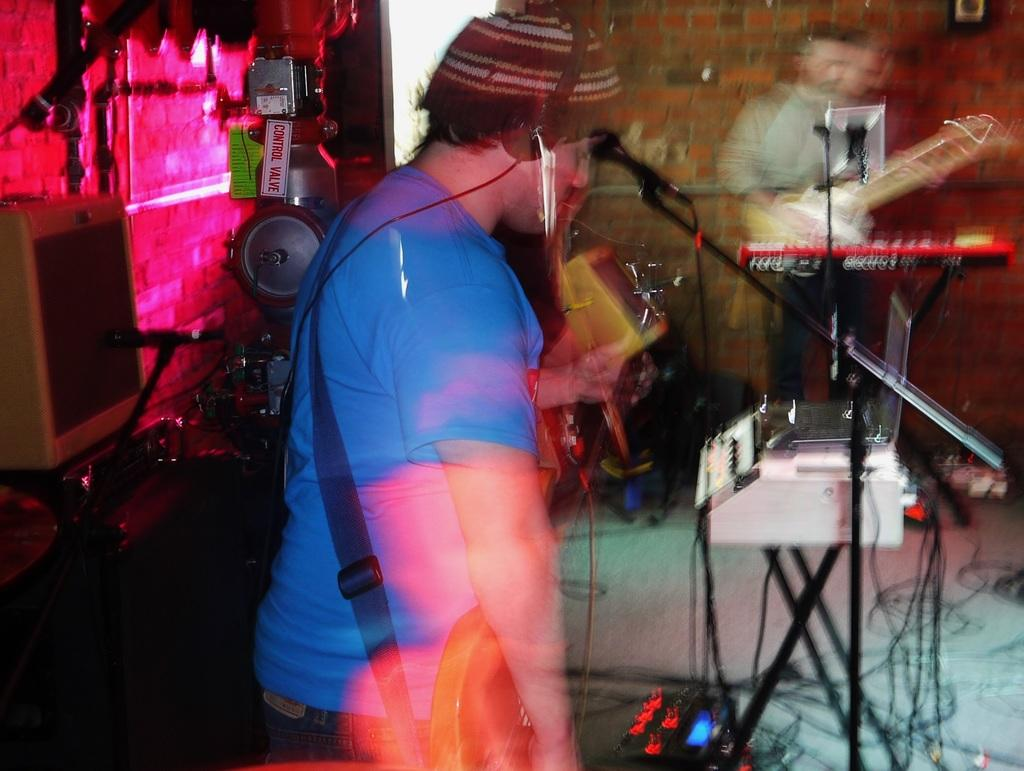What is the man in the image holding? The man is holding a guitar. Can you describe the man's attire in the image? The man is wearing a cap and a headphone. What other object is present in the image? There is a mic in the image. Are there any other people in the image? Yes, there is another person in the image. What is the other person holding? The other person is holding a guitar. What type of ornament is hanging from the guitar in the image? There is no ornament hanging from the guitar in the image. Can you describe the ground in the image? The ground is not visible in the image; it only shows the man and the other person holding guitars, along with the mic and their attire. 